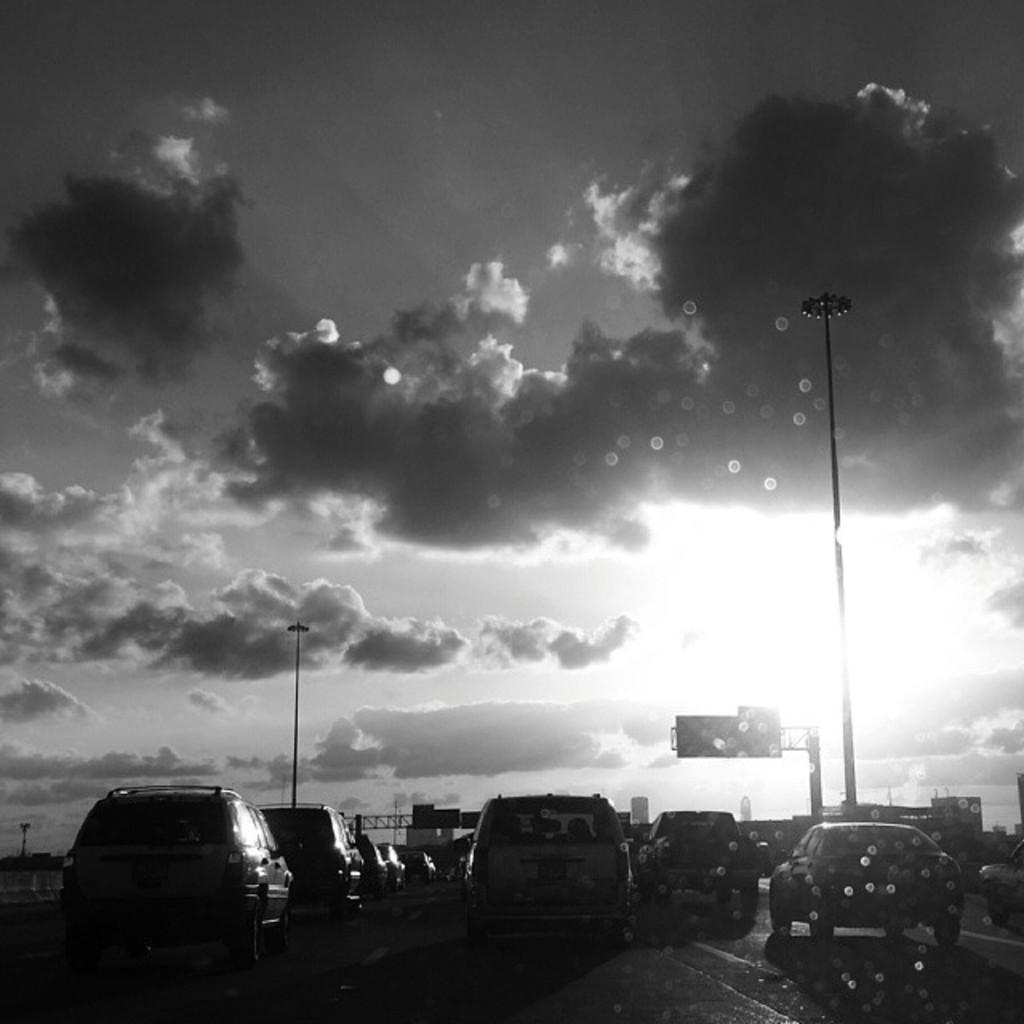Describe this image in one or two sentences. In this image we can see so many cars are moving on road, beside road poles are there. The sky is full of clouds. 